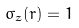<formula> <loc_0><loc_0><loc_500><loc_500>\sigma _ { z } ( { r } ) = 1</formula> 